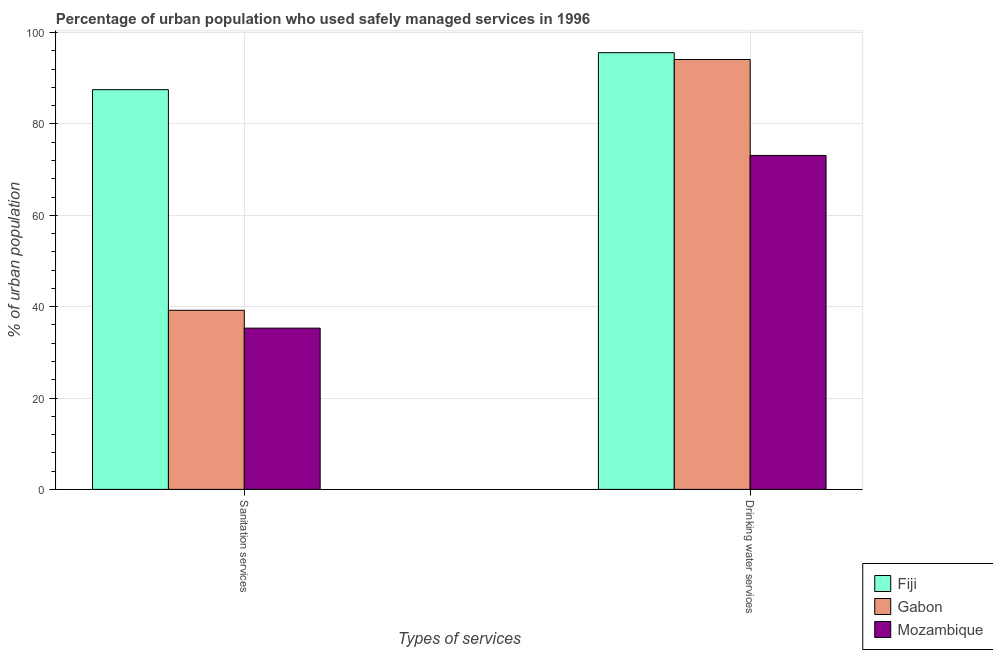How many different coloured bars are there?
Provide a short and direct response. 3. How many groups of bars are there?
Your response must be concise. 2. Are the number of bars on each tick of the X-axis equal?
Your answer should be very brief. Yes. How many bars are there on the 2nd tick from the left?
Offer a very short reply. 3. What is the label of the 2nd group of bars from the left?
Your response must be concise. Drinking water services. What is the percentage of urban population who used drinking water services in Mozambique?
Provide a short and direct response. 73.1. Across all countries, what is the maximum percentage of urban population who used sanitation services?
Ensure brevity in your answer.  87.5. Across all countries, what is the minimum percentage of urban population who used sanitation services?
Provide a succinct answer. 35.3. In which country was the percentage of urban population who used drinking water services maximum?
Offer a very short reply. Fiji. In which country was the percentage of urban population who used sanitation services minimum?
Give a very brief answer. Mozambique. What is the total percentage of urban population who used sanitation services in the graph?
Your answer should be very brief. 162. What is the difference between the percentage of urban population who used sanitation services in Gabon and that in Fiji?
Give a very brief answer. -48.3. What is the difference between the percentage of urban population who used sanitation services in Mozambique and the percentage of urban population who used drinking water services in Gabon?
Your response must be concise. -58.8. What is the average percentage of urban population who used drinking water services per country?
Ensure brevity in your answer.  87.6. What is the difference between the percentage of urban population who used sanitation services and percentage of urban population who used drinking water services in Mozambique?
Offer a terse response. -37.8. What is the ratio of the percentage of urban population who used drinking water services in Mozambique to that in Gabon?
Offer a terse response. 0.78. Is the percentage of urban population who used drinking water services in Mozambique less than that in Gabon?
Your response must be concise. Yes. In how many countries, is the percentage of urban population who used sanitation services greater than the average percentage of urban population who used sanitation services taken over all countries?
Your answer should be very brief. 1. What does the 2nd bar from the left in Drinking water services represents?
Your answer should be very brief. Gabon. What does the 1st bar from the right in Sanitation services represents?
Give a very brief answer. Mozambique. How many bars are there?
Your answer should be compact. 6. Are all the bars in the graph horizontal?
Provide a succinct answer. No. How many countries are there in the graph?
Give a very brief answer. 3. Does the graph contain any zero values?
Your answer should be compact. No. What is the title of the graph?
Your answer should be very brief. Percentage of urban population who used safely managed services in 1996. What is the label or title of the X-axis?
Your answer should be compact. Types of services. What is the label or title of the Y-axis?
Provide a short and direct response. % of urban population. What is the % of urban population of Fiji in Sanitation services?
Offer a terse response. 87.5. What is the % of urban population of Gabon in Sanitation services?
Provide a succinct answer. 39.2. What is the % of urban population in Mozambique in Sanitation services?
Ensure brevity in your answer.  35.3. What is the % of urban population in Fiji in Drinking water services?
Your answer should be compact. 95.6. What is the % of urban population of Gabon in Drinking water services?
Your response must be concise. 94.1. What is the % of urban population of Mozambique in Drinking water services?
Ensure brevity in your answer.  73.1. Across all Types of services, what is the maximum % of urban population in Fiji?
Offer a terse response. 95.6. Across all Types of services, what is the maximum % of urban population of Gabon?
Make the answer very short. 94.1. Across all Types of services, what is the maximum % of urban population in Mozambique?
Offer a very short reply. 73.1. Across all Types of services, what is the minimum % of urban population of Fiji?
Give a very brief answer. 87.5. Across all Types of services, what is the minimum % of urban population of Gabon?
Make the answer very short. 39.2. Across all Types of services, what is the minimum % of urban population in Mozambique?
Your answer should be very brief. 35.3. What is the total % of urban population in Fiji in the graph?
Your response must be concise. 183.1. What is the total % of urban population in Gabon in the graph?
Offer a terse response. 133.3. What is the total % of urban population of Mozambique in the graph?
Offer a very short reply. 108.4. What is the difference between the % of urban population of Gabon in Sanitation services and that in Drinking water services?
Make the answer very short. -54.9. What is the difference between the % of urban population in Mozambique in Sanitation services and that in Drinking water services?
Ensure brevity in your answer.  -37.8. What is the difference between the % of urban population of Fiji in Sanitation services and the % of urban population of Gabon in Drinking water services?
Provide a succinct answer. -6.6. What is the difference between the % of urban population of Fiji in Sanitation services and the % of urban population of Mozambique in Drinking water services?
Your response must be concise. 14.4. What is the difference between the % of urban population in Gabon in Sanitation services and the % of urban population in Mozambique in Drinking water services?
Give a very brief answer. -33.9. What is the average % of urban population of Fiji per Types of services?
Your answer should be compact. 91.55. What is the average % of urban population of Gabon per Types of services?
Offer a very short reply. 66.65. What is the average % of urban population of Mozambique per Types of services?
Ensure brevity in your answer.  54.2. What is the difference between the % of urban population of Fiji and % of urban population of Gabon in Sanitation services?
Make the answer very short. 48.3. What is the difference between the % of urban population of Fiji and % of urban population of Mozambique in Sanitation services?
Provide a succinct answer. 52.2. What is the ratio of the % of urban population of Fiji in Sanitation services to that in Drinking water services?
Your response must be concise. 0.92. What is the ratio of the % of urban population in Gabon in Sanitation services to that in Drinking water services?
Keep it short and to the point. 0.42. What is the ratio of the % of urban population of Mozambique in Sanitation services to that in Drinking water services?
Offer a terse response. 0.48. What is the difference between the highest and the second highest % of urban population in Gabon?
Keep it short and to the point. 54.9. What is the difference between the highest and the second highest % of urban population of Mozambique?
Give a very brief answer. 37.8. What is the difference between the highest and the lowest % of urban population in Gabon?
Provide a short and direct response. 54.9. What is the difference between the highest and the lowest % of urban population in Mozambique?
Keep it short and to the point. 37.8. 